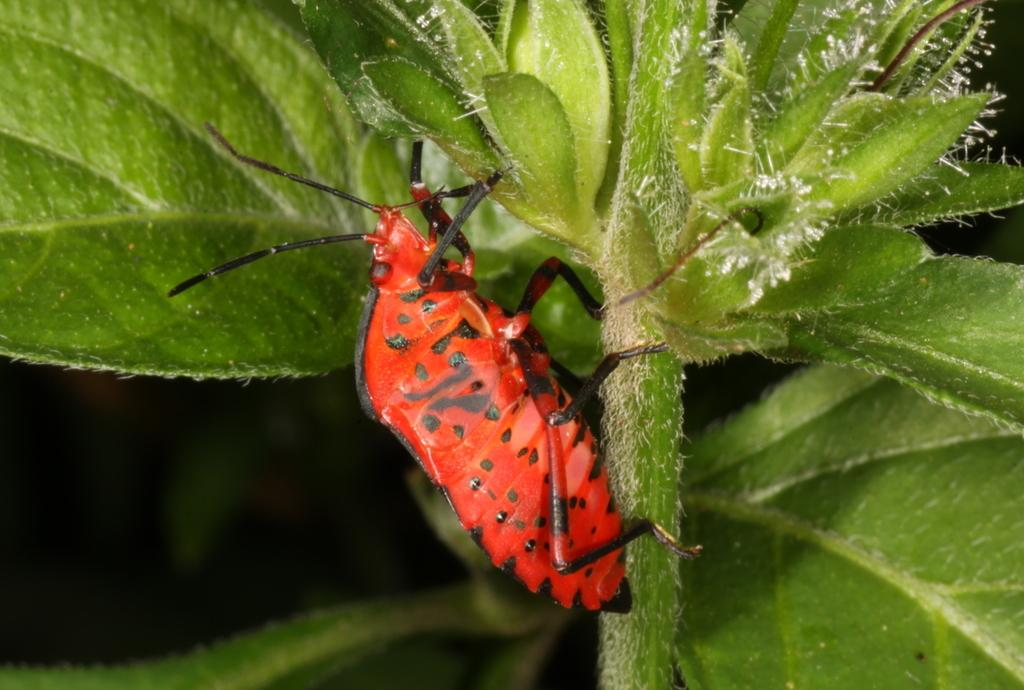What type of insect is visible in the image? There is a red-colored insect in the image. Where is the insect located? The insect is on a stem. What can be seen in the background of the image? There are green leaves in the background of the image. Can you hear the insect making any noise in the image? There is no indication of sound in the image, so it cannot be determined if the insect is making any noise. 